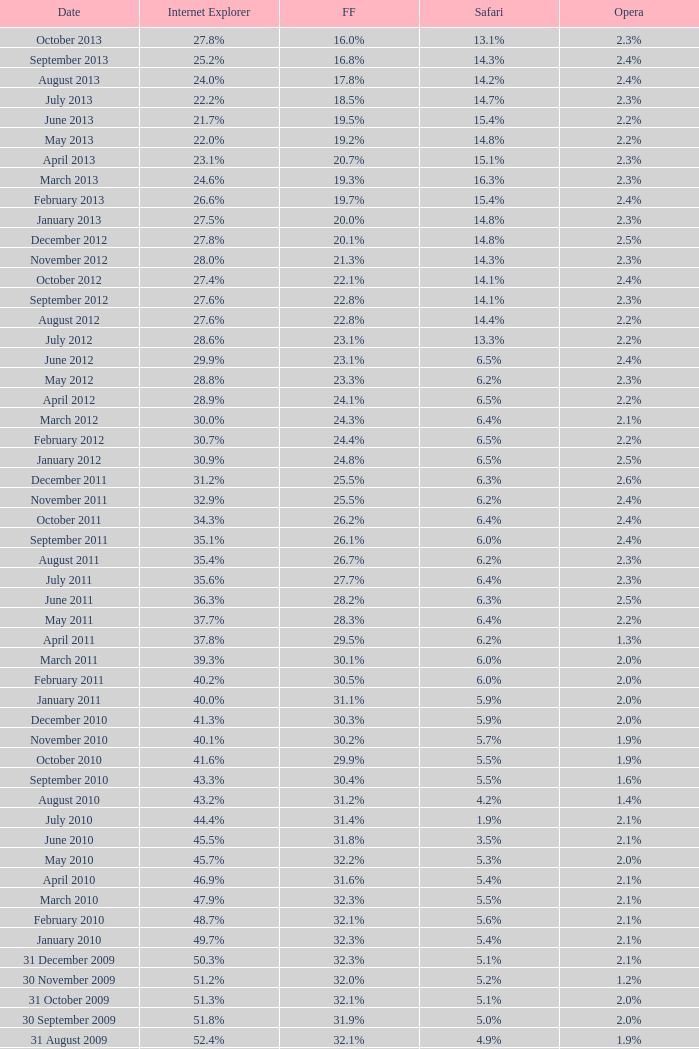What is the safari value with a 28.0% internet explorer? 14.3%. 